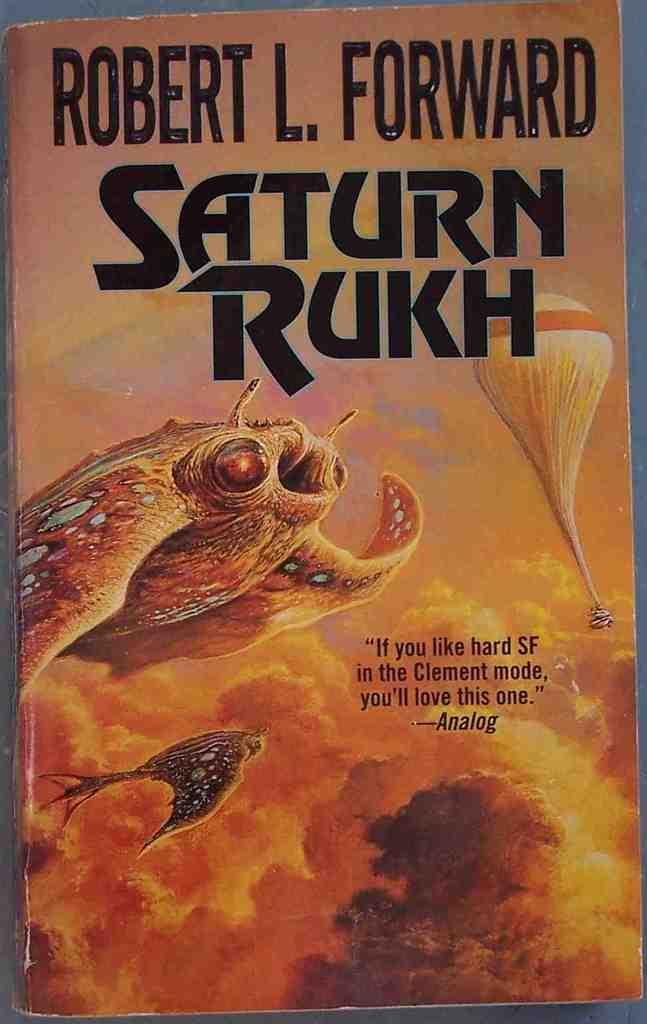Provide a one-sentence caption for the provided image. the title of the book is Saturn Rukh. 